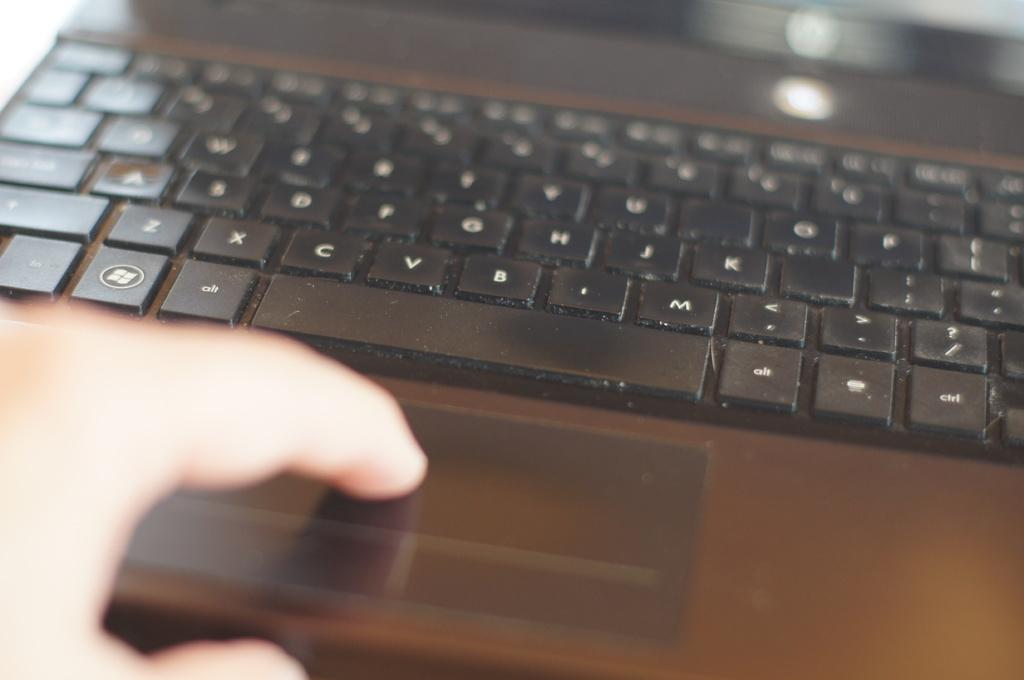What electronic device is present in the image? There is a laptop in the picture. What feature does the laptop have? The laptop has keys. Who is interacting with the laptop in the image? There is a person operating the laptop. Can you tell me how deep the river is in the image? There is no river present in the image; it features a laptop with a person operating it. What type of trade is being conducted in the image? There is no trade being conducted in the image; it only shows a person using a laptop. 